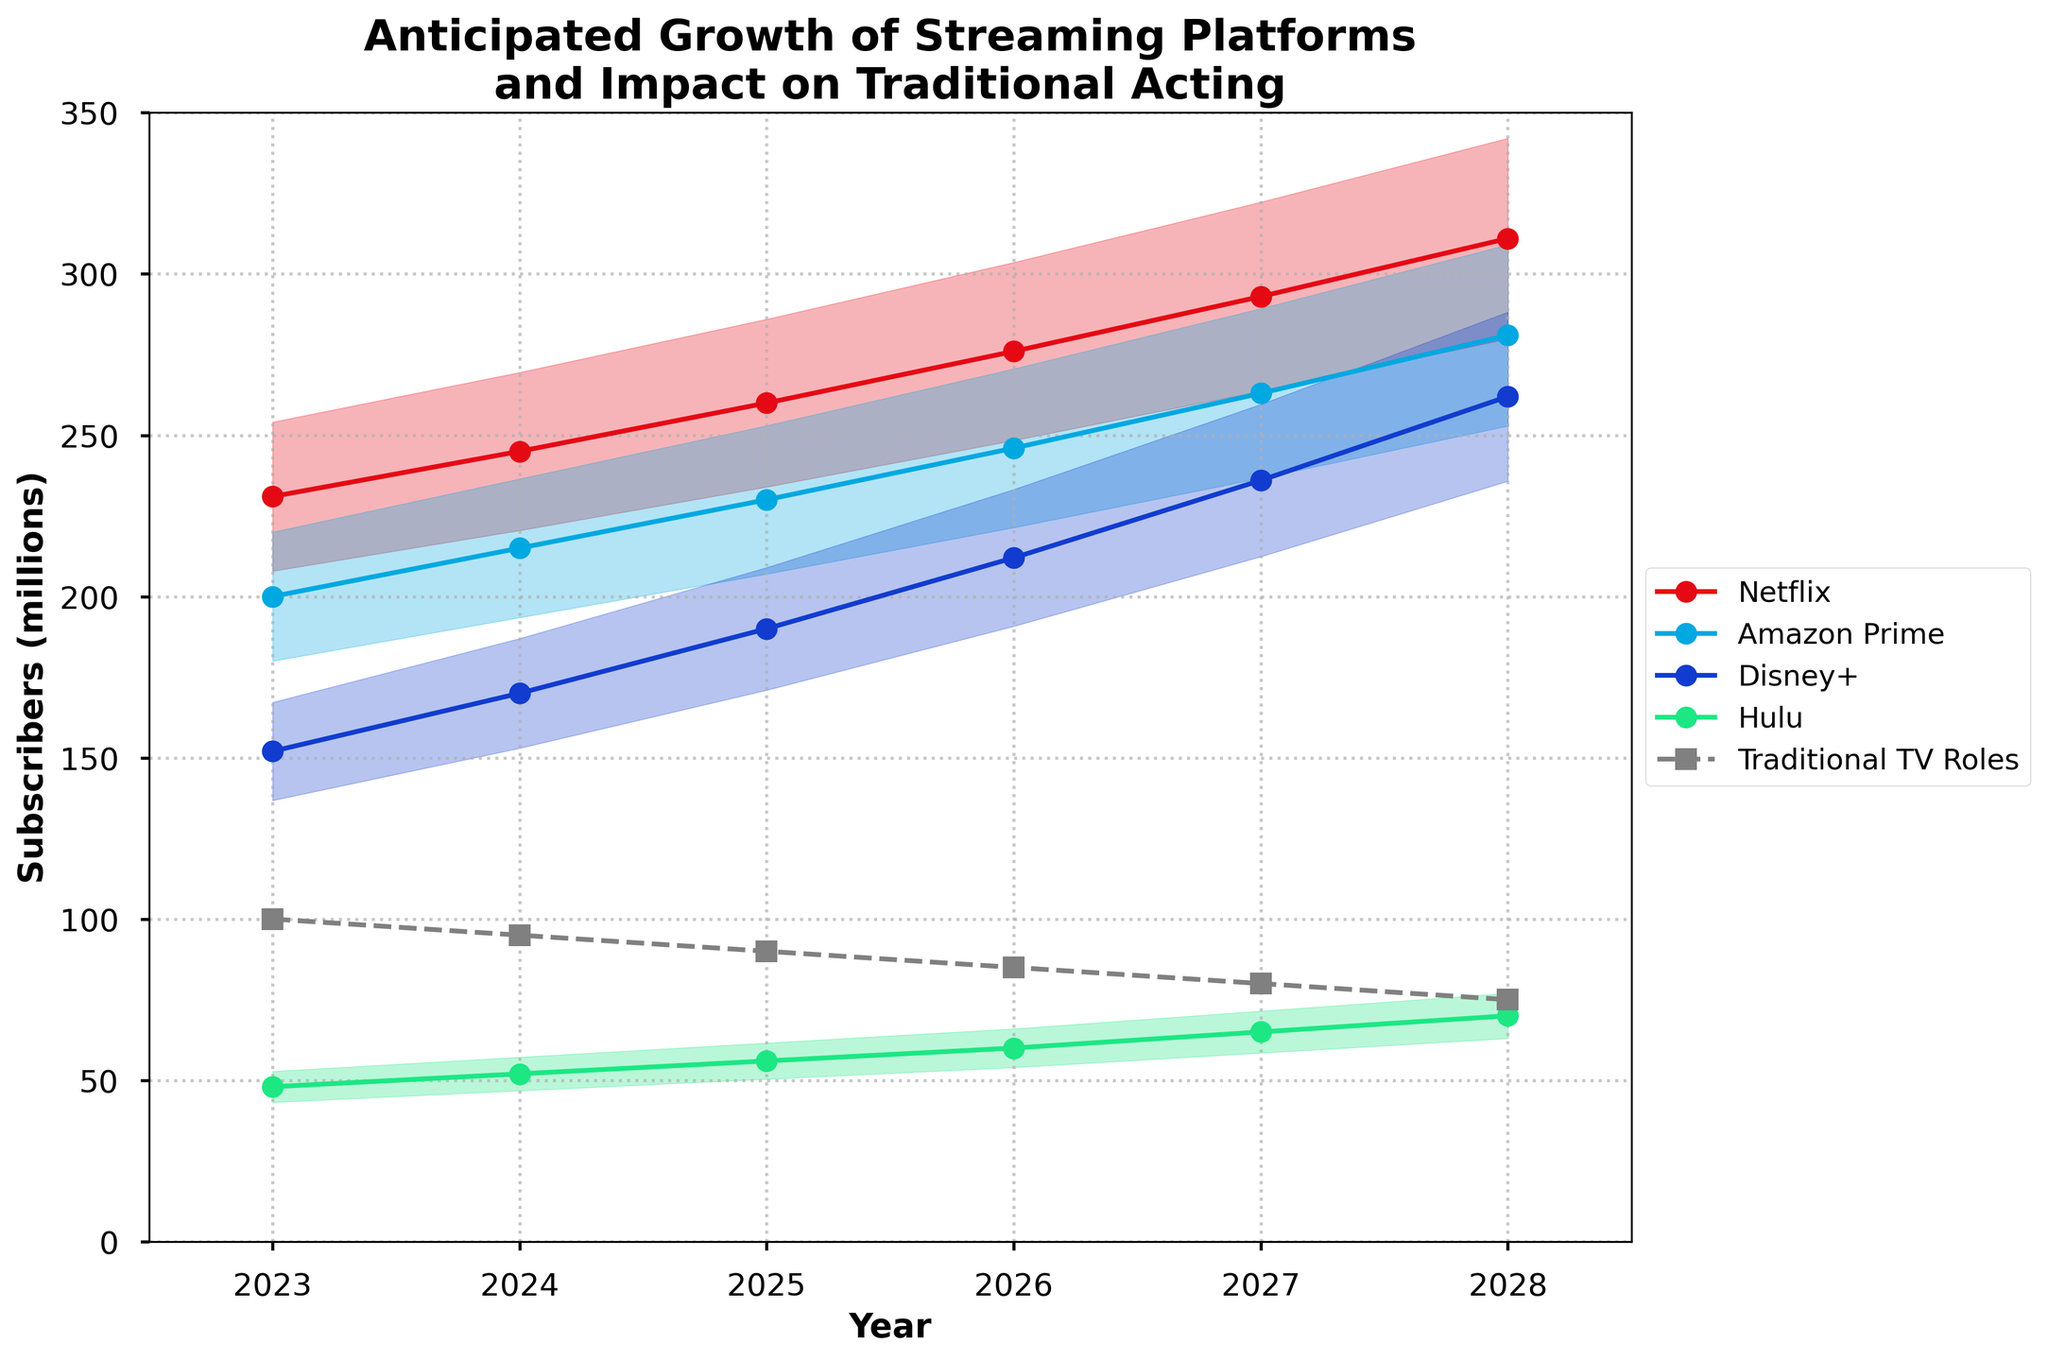What is the title of the plot? The title of the plot is displayed at the top center and reads 'Anticipated Growth of Streaming Platforms and Impact on Traditional Acting'.
Answer: Anticipated Growth of Streaming Platforms and Impact on Traditional Acting What do the filled regions around each line represent? The filled regions around each line represent the anticipated range of subscriber growth for each platform, showing a 10% margin (from 90% to 110% of the central value).
Answer: Anticipated range of subscriber growth Which streaming platform is projected to have the highest number of subscribers in 2028? Look at the lines representing each platform and their projected values in the year 2028. The platform with the highest line value at 2028 is Netflix, reaching 311 million subscribers.
Answer: Netflix By how much are Traditional TV Roles expected to decline from 2023 to 2028? The value for Traditional TV Roles in 2023 is 100 and in 2028 is 75. The decline can be calculated as 100 - 75 = 25.
Answer: 25 How do Amazon Prime subscribers in 2024 compare to Disney+ subscribers in 2024? Refer to the lines for Amazon Prime and Disney+ in 2024. Amazon Prime has 215 million subscribers, while Disney+ has 170 million subscribers. Therefore, Amazon Prime has more subscribers.
Answer: Amazon Prime has more subscribers What is the projected average number of Hulu subscribers between 2025 and 2027? Add the Hulu values for 2025, 2026, and 2027, then divide by 3: (56 + 60 + 65) / 3 = 181 / 3 ≈ 60.3.
Answer: ≈ 60.3 Which platform shows the most consistent year-over-year growth in the given period? Assess the slopes of the lines representing each platform. The line for Netflix is the most steadily increasing, indicating consistent year-over-year growth.
Answer: Netflix What is the difference in projected subscribers between Netflix and Hulu in 2026? In 2026, Netflix has 276 million subscribers, and Hulu has 60 million subscribers. The difference is 276 - 60 = 216.
Answer: 216 In 2025, by how much do Amazon Prime subscribers exceed Traditional TV Roles? Amazon Prime has 230 million subscribers, and Traditional TV Roles have 90. The difference is 230 - 90 = 140.
Answer: 140 Compare the trend of Disney+ with Hulu from 2023 to 2028. Both platforms show an increasing trend, but Disney+ starts higher (152) and ends much higher (262) compared to Hulu, which starts at 48 and ends at 70. Disney+ grows more rapidly than Hulu.
Answer: Disney+ grows more rapidly 